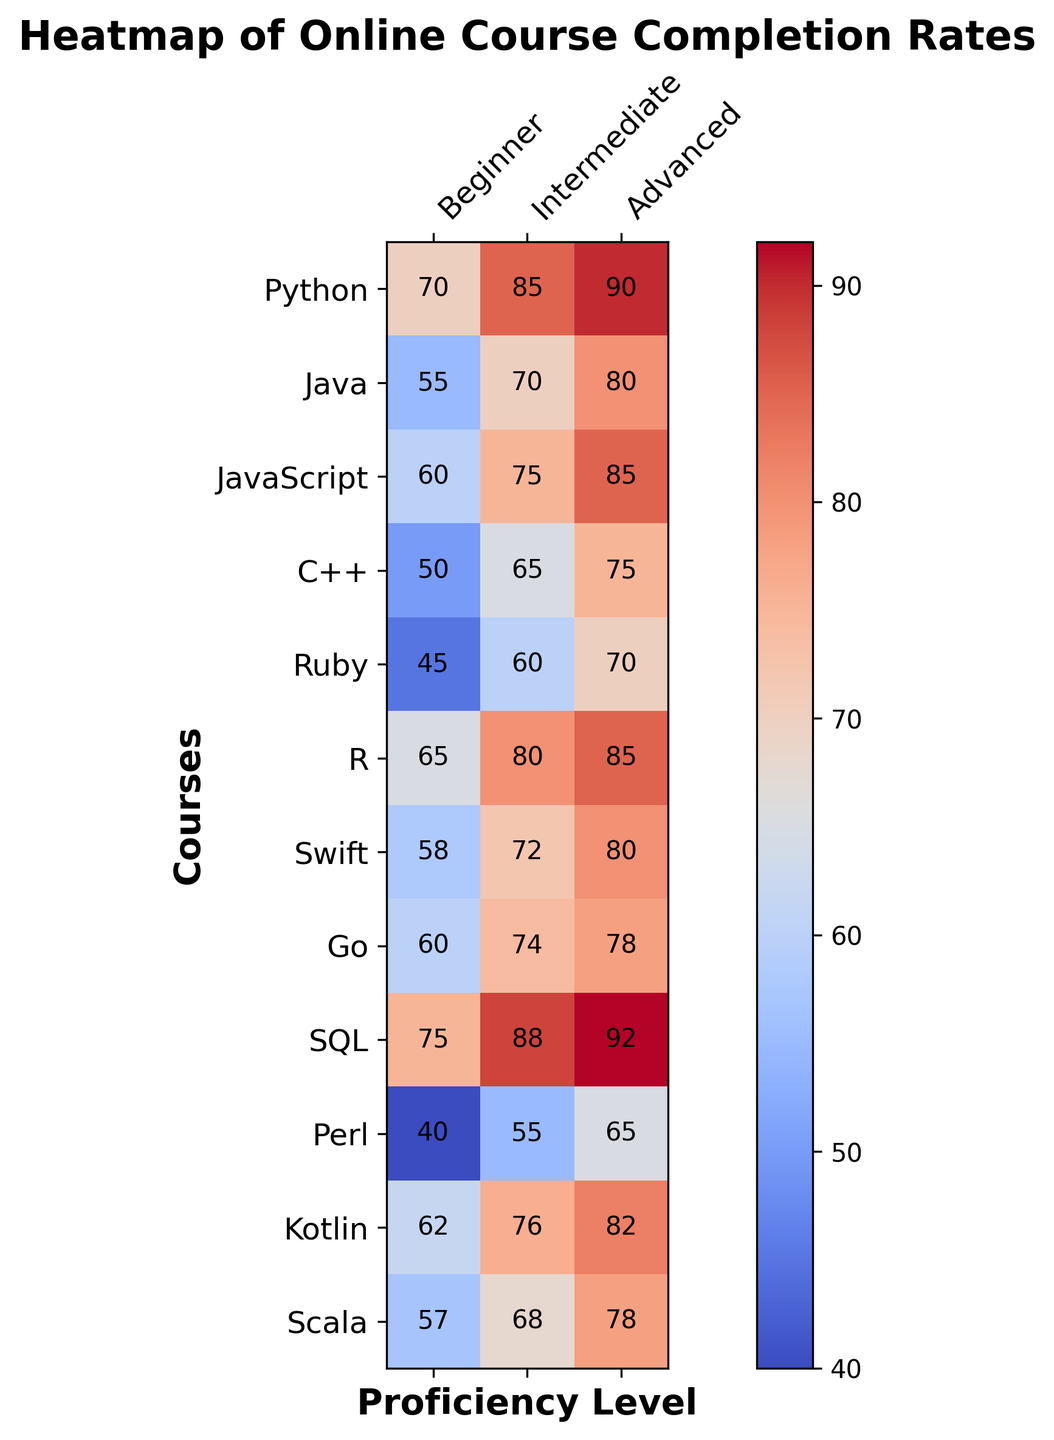Which course has the highest completion rate for beginners? Scan the "Beginner" column to identify the highest value. The highest completion rate for beginners is 75 in the SQL row.
Answer: SQL Which course has the lowest completion rate for advanced students? Look down the "Advanced" column to find the smallest value. The lowest completion rate is 65 in the Perl row.
Answer: Perl What's the average completion rate for the Kotlin course across all proficiency levels? Add the values for Kotlin across all proficiency levels: 62 + 76 + 82 = 220, then divide by the number of levels, which is 3. The average is 220/3 ≈ 73.33
Answer: 73.33 Compare the completion rates for Python and Ruby at the intermediate level. Which one is higher? Look at the "Intermediate" column values for Python (85) and Ruby (60). Python's completion rate is higher.
Answer: Python Is the completion rate for advanced students usually higher across all courses compared to beginners? Visually inspect the heatmap to compare the "Advanced" column generally being darker (higher values) than the "Beginner" column across most courses.
Answer: Yes Among Python, Java, and JavaScript, which course shows the greatest improvement from beginner to advanced levels? Calculate the difference from beginner to advanced for each: Python (90 - 70 = 20), Java (80 - 55 = 25), JavaScript (85 - 60 = 25). The greatest improvement is shown by Java and JavaScript.
Answer: Java and JavaScript What is the range of completion rates for R across different proficiency levels? Identify the minimum and maximum values for R across all levels (65, 80, 85). The range is the difference between the maximum and minimum values: 85 - 65 = 20.
Answer: 20 Which proficiency level has the most variation in completion rates across all courses, and how do you determine it? Calculate the range for each proficiency level by finding the difference between the highest and lowest values: Beginner (75-40=35), Intermediate (88-55=33), Advanced (92-65=27). The Beginner shows the most variation.
Answer: Beginner In which course do intermediate students outperform beginners the most? Calculate the difference for each course between beginner and intermediate levels. The largest difference is for Perl: 55 - 40 = 15.
Answer: Perl What is the overall median completion rate for all the data points presented in the heatmap? Arrange all the rates in order: 40, 45, 50, 55, 55, 57, 58, 60, 60, 60, 62, 65, 65, 65, 68, 70, 70, 72, 74, 75, 75, 76, 78, 78, 80, 80, 82, 85, 85, 85, 85, 88, 90, 92. The median is the middle value in this ordered list, which is the average of 76 and 78: (76+78)/2 = 77.
Answer: 77 